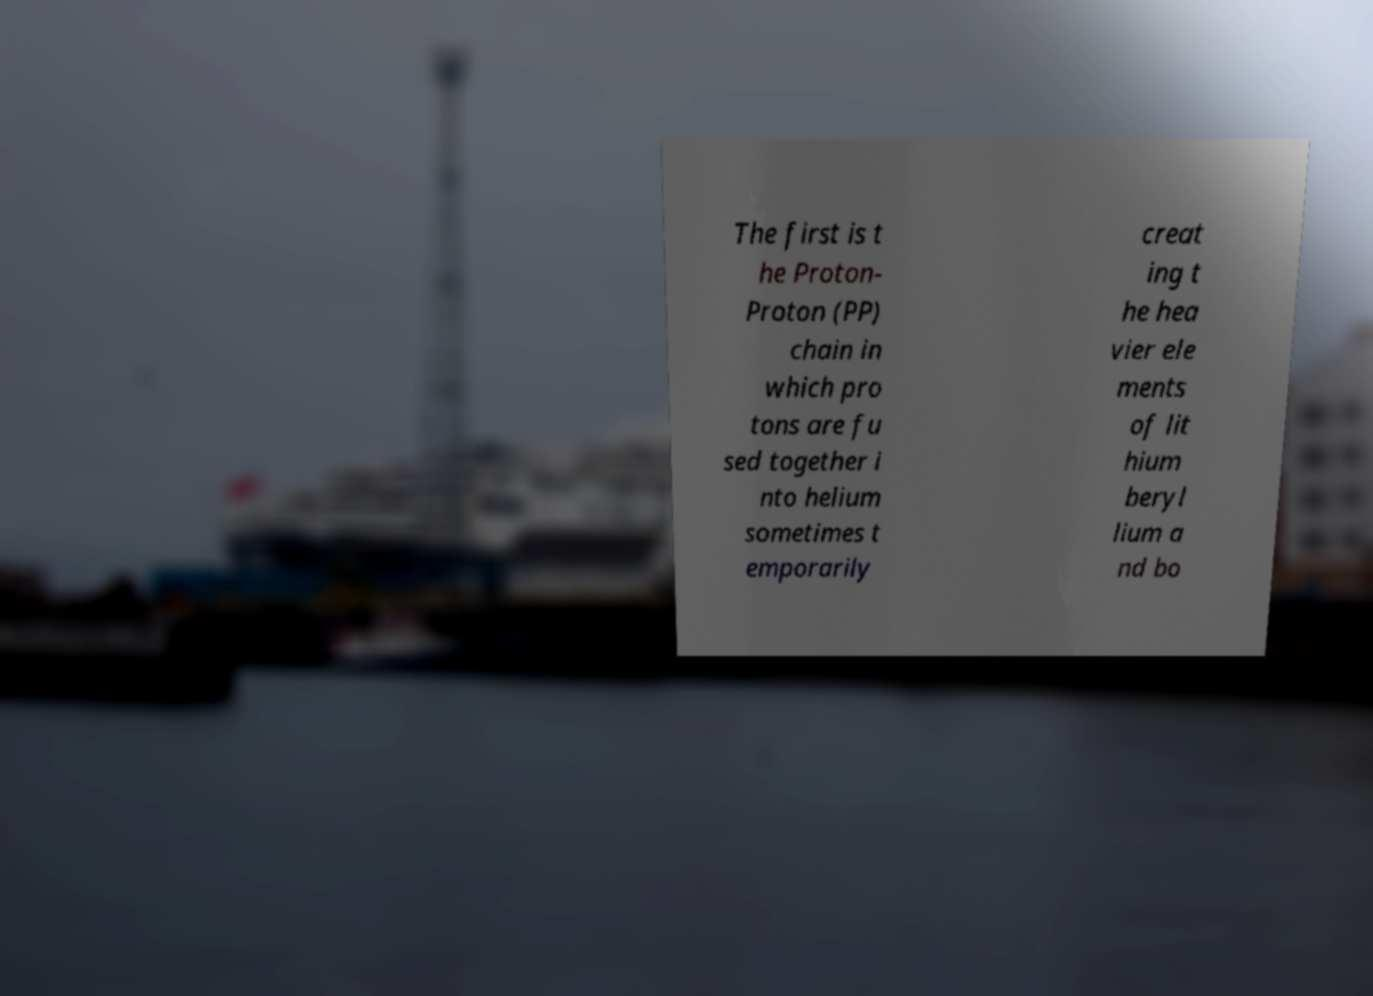Please identify and transcribe the text found in this image. The first is t he Proton- Proton (PP) chain in which pro tons are fu sed together i nto helium sometimes t emporarily creat ing t he hea vier ele ments of lit hium beryl lium a nd bo 